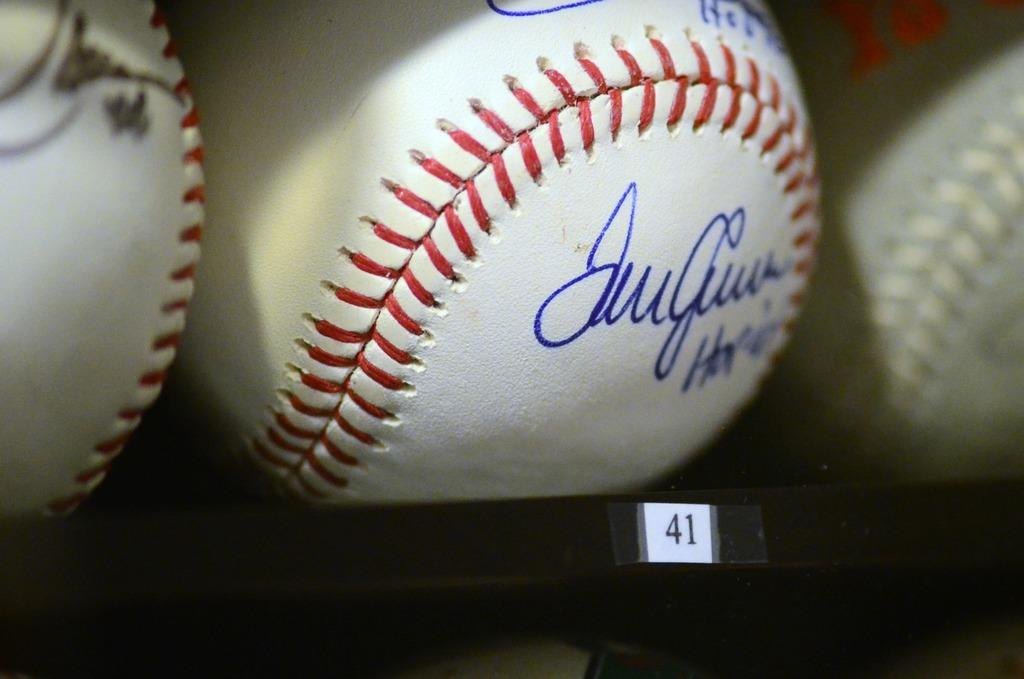<image>
Summarize the visual content of the image. A signed baseball on a shelf with the labeling 41. 